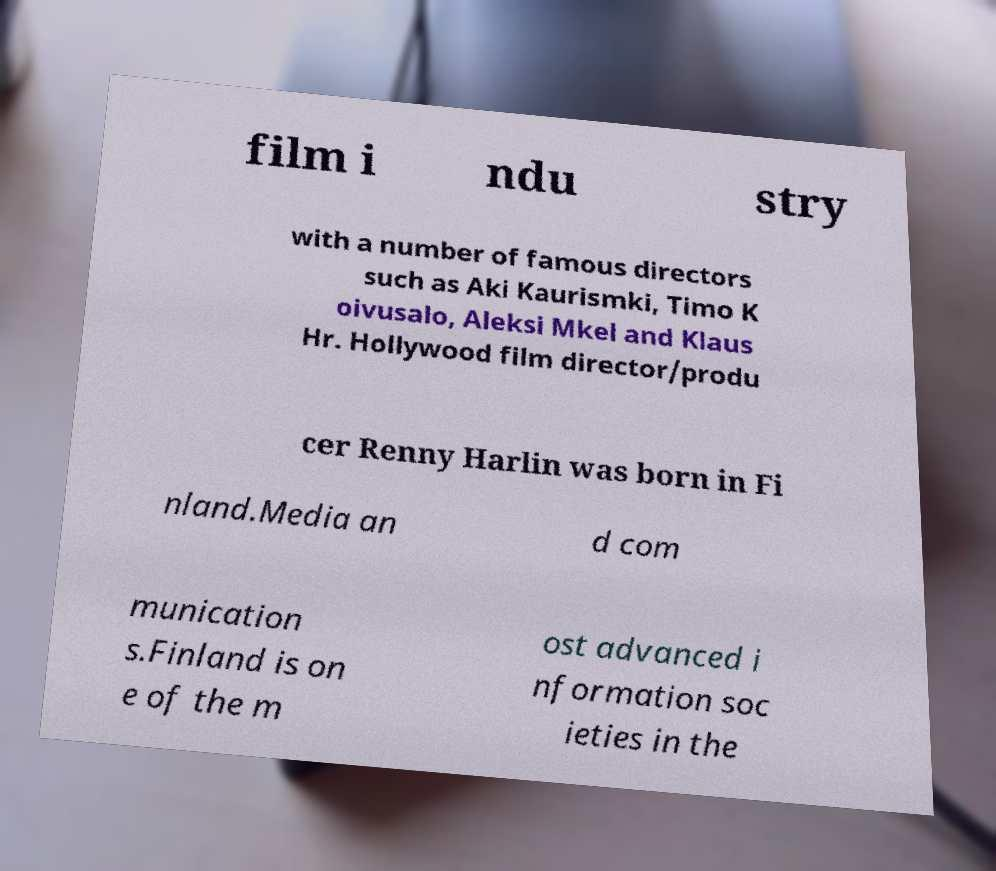I need the written content from this picture converted into text. Can you do that? film i ndu stry with a number of famous directors such as Aki Kaurismki, Timo K oivusalo, Aleksi Mkel and Klaus Hr. Hollywood film director/produ cer Renny Harlin was born in Fi nland.Media an d com munication s.Finland is on e of the m ost advanced i nformation soc ieties in the 